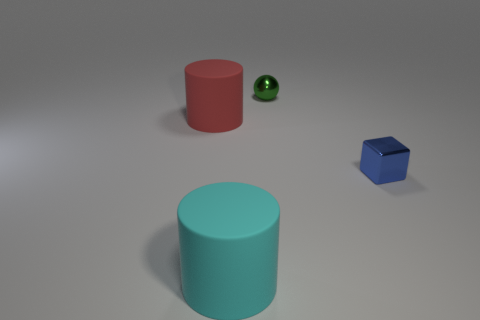Are there any tiny green metal spheres right of the metal cube?
Your answer should be very brief. No. How many large gray metallic cubes are there?
Provide a short and direct response. 0. There is a thing that is in front of the tiny shiny block; what number of large cyan rubber cylinders are in front of it?
Keep it short and to the point. 0. Does the sphere have the same color as the tiny metallic thing in front of the small green thing?
Ensure brevity in your answer.  No. How many other matte things have the same shape as the cyan object?
Offer a terse response. 1. What is the tiny object that is in front of the tiny green ball made of?
Provide a succinct answer. Metal. Does the big rubber thing behind the cyan cylinder have the same shape as the cyan matte thing?
Offer a very short reply. Yes. Are there any other balls of the same size as the green ball?
Your answer should be very brief. No. There is a green thing; is its shape the same as the rubber thing in front of the small blue cube?
Offer a terse response. No. Is the number of things that are left of the green object less than the number of shiny spheres?
Make the answer very short. No. 